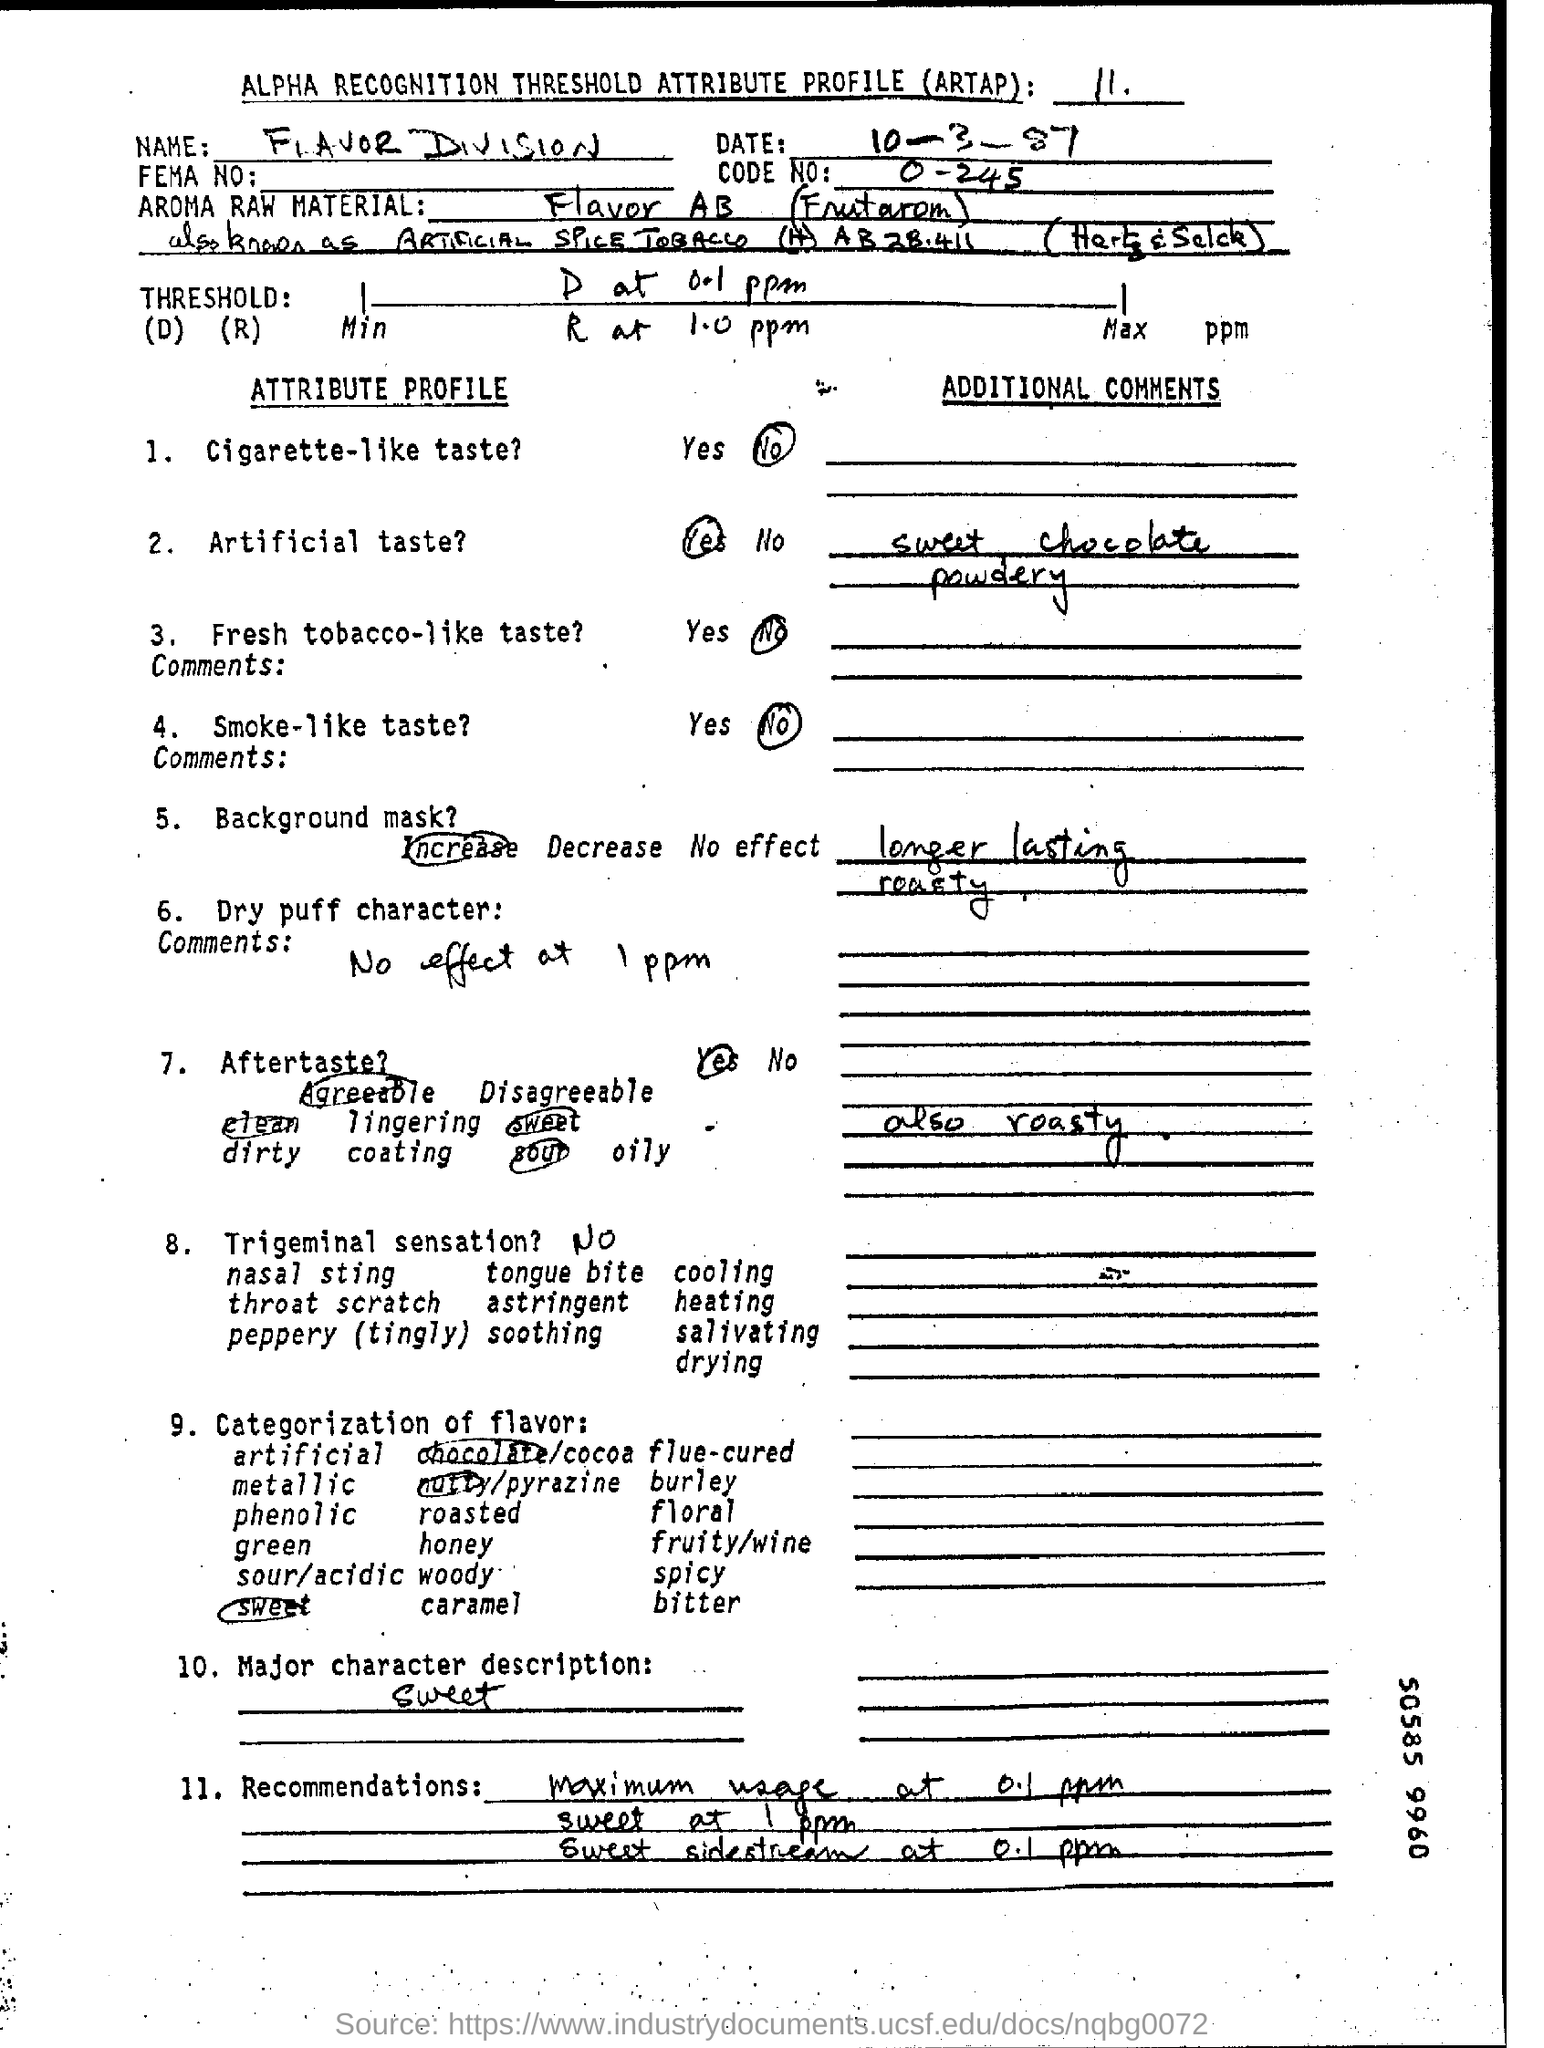What is the Name given in this document?
Ensure brevity in your answer.  Flavor division. What is the fullform of ARTAP?
Keep it short and to the point. ALPHA RECOGNITION THRESHOLD ATTRIBUTE PROFILE. What is the Code No mentioned in the document?
Offer a very short reply. 0 -245. What is mentioned in the major character description as per the attribute profile?
Provide a succinct answer. Sweet. Does the product gives a cigarette- like taste?
Provide a succinct answer. No. What is the date mentioned in this document?
Your response must be concise. 10-3-87. Which Aroma Raw Material is used here?
Your answer should be compact. Flavor AB (Frutarom). 